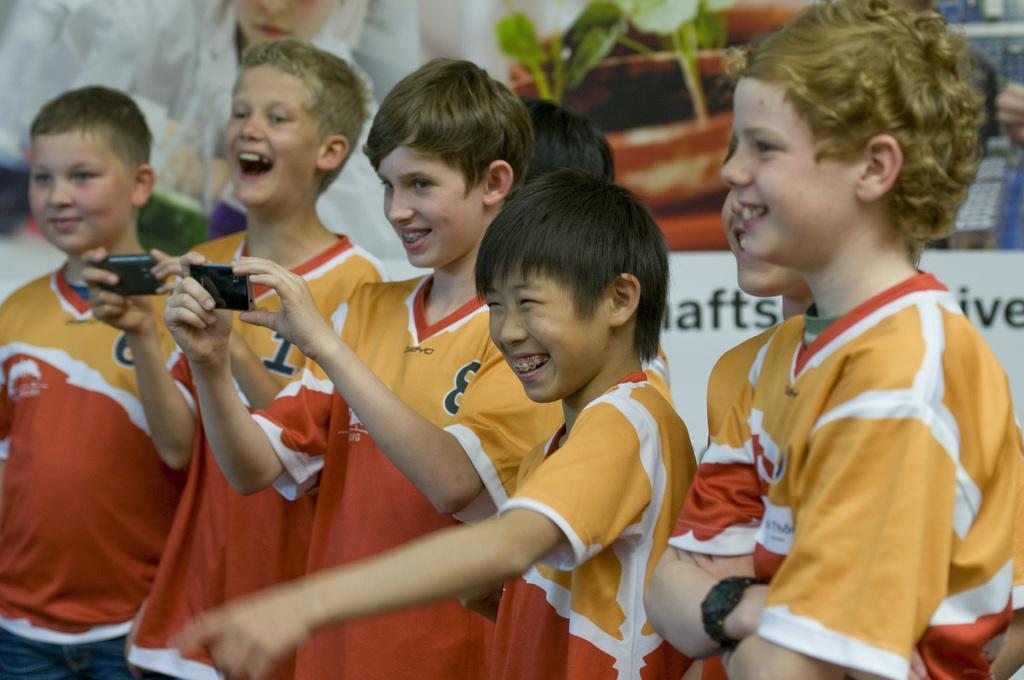<image>
Relay a brief, clear account of the picture shown. A group of boys laugh as a boy with the 8 jersey takes a picture. 